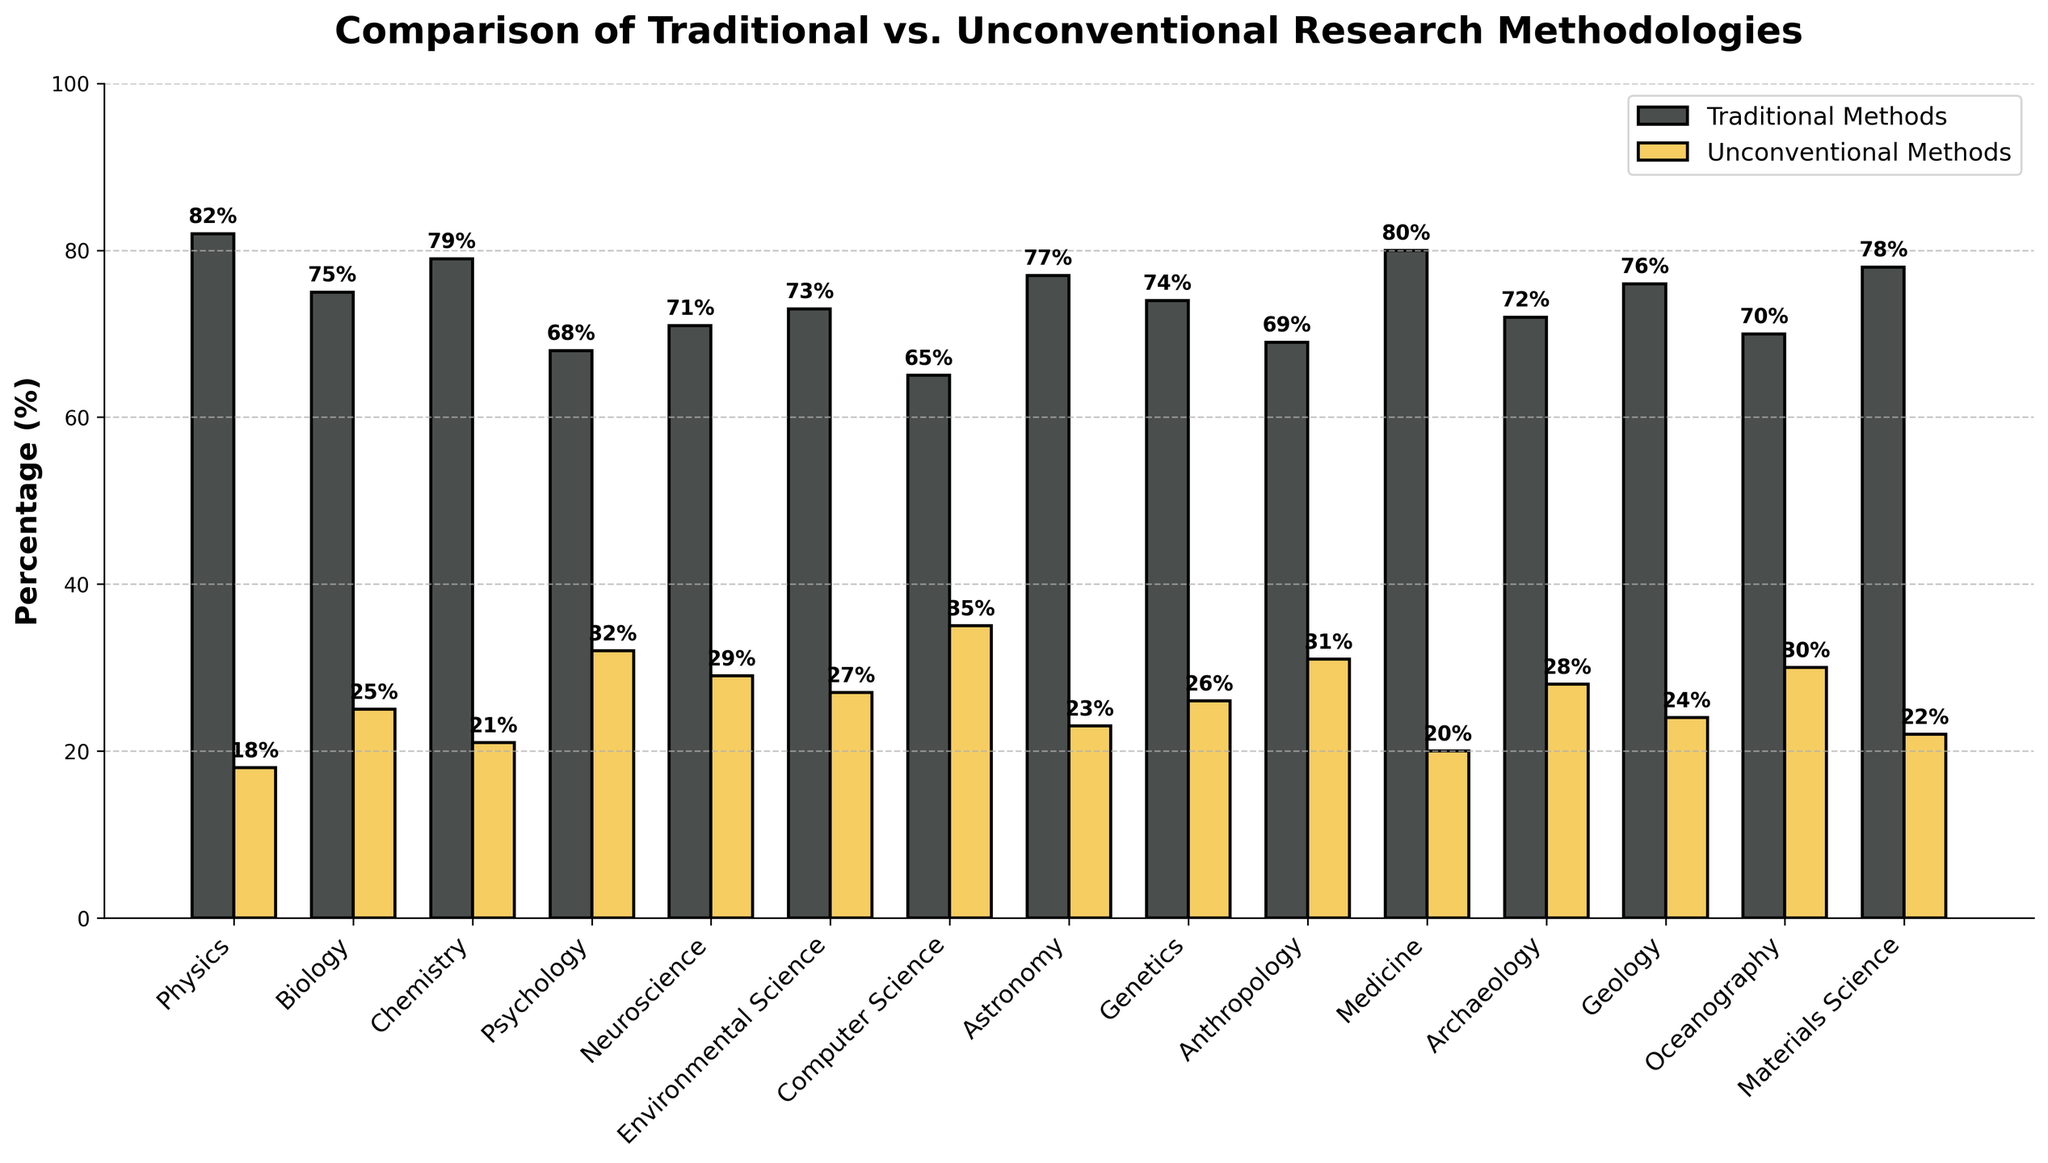What discipline uses unconventional methods the most? We compare the heights of the bars representing unconventional methods across all disciplines. The highest bar indicates the most usage.
Answer: Computer Science In which discipline is the percentage difference between traditional and unconventional methods the smallest? Calculate the difference between traditional and unconventional percentages for each discipline and compare them. The smallest difference indicates the answer.
Answer: Biology What is the combined percentage of traditional methods in Physics and Chemistry? Add the traditional methods percentages for Physics (82) and Chemistry (79).
Answer: 161% Which two disciplines have the closest percentages of unconventional methods? Compare the unconventional percentages and find the two with the smallest numerical difference between them.
Answer: Biology and Genetics How many disciplines have more than 30% unconventional methods? Count the number of bars representing unconventional methods that exceed the 30% height threshold.
Answer: 3 What is the average percentage of traditional methods across all disciplines? Sum the traditional methods percentages for all disciplines and divide by the total number of disciplines (15).
Answer: 74.67% Which discipline has a lower percentage of traditional methods than Neuroscience but higher than Environmental Science? Find the traditional methods percentage for Neuroscience (71) and Environmental Science (73), and identify the discipline within this range.
Answer: Archaeology How does the percentage of unconventional methods in Psychology compare to that in Medicine? Compare the heights of the bars representing unconventional methods for Psychology (32) and Medicine (20).
Answer: Psychology has 12% more Which discipline shows the largest disparity between traditional and unconventional methods? Calculate the difference between traditional and unconventional percentages for each discipline and identify the largest disparity.
Answer: Physics What is the total percentage representation for both types of methodologies in Oceanography? Sum the traditional (70) and unconventional (30) percentages for Oceanography.
Answer: 100% 